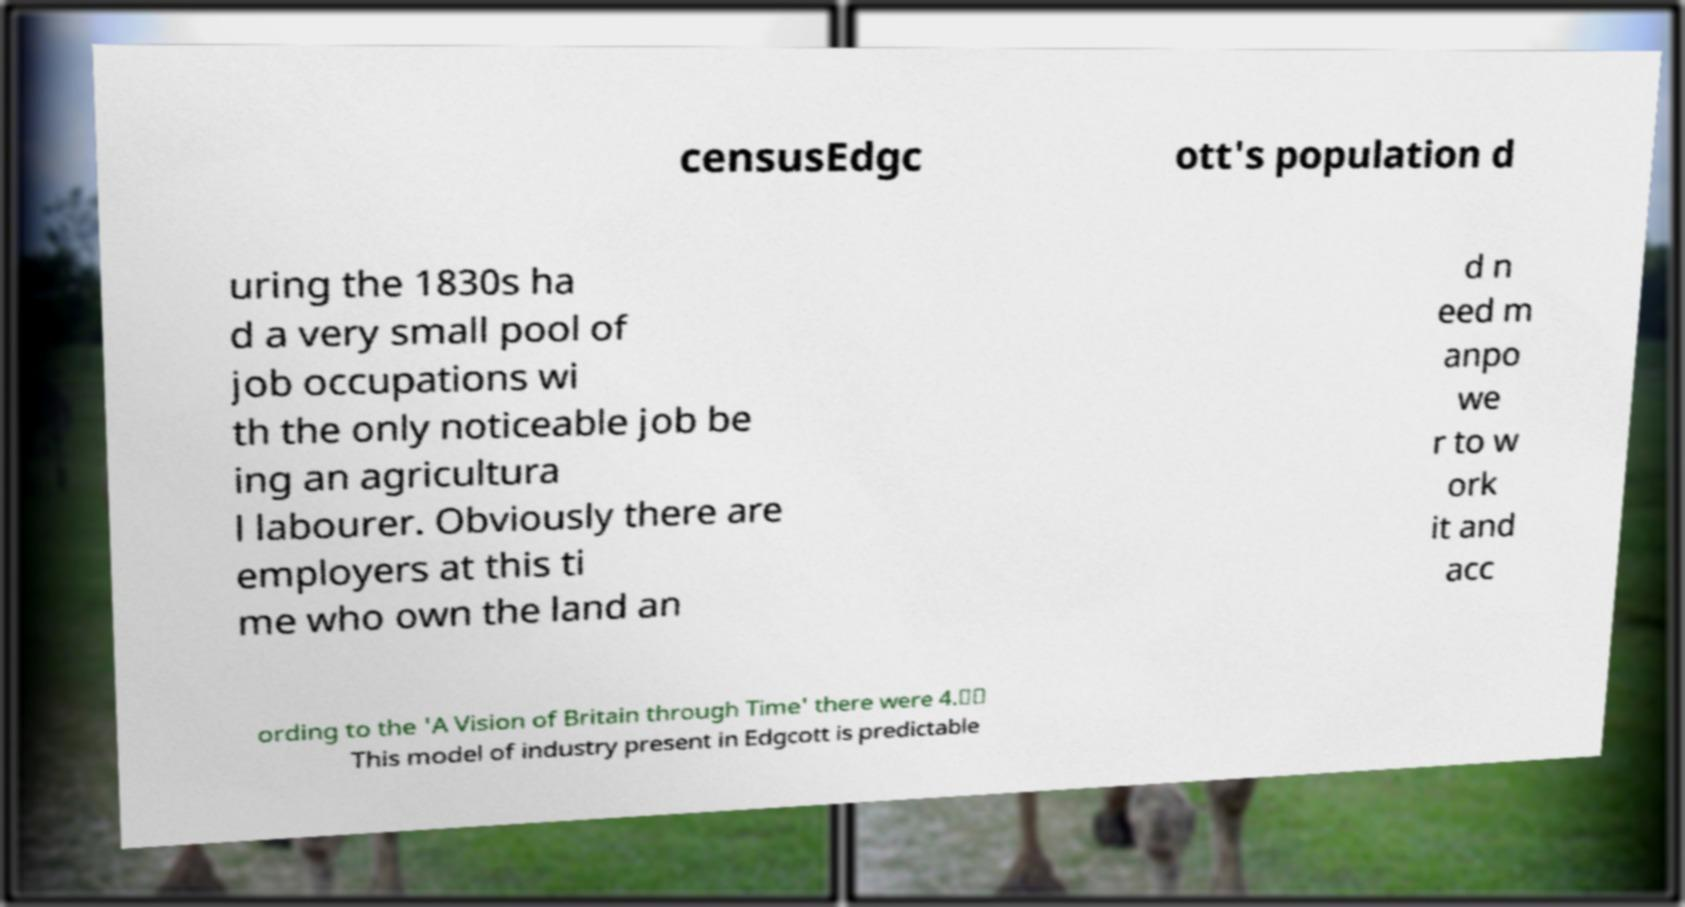Could you extract and type out the text from this image? censusEdgc ott's population d uring the 1830s ha d a very small pool of job occupations wi th the only noticeable job be ing an agricultura l labourer. Obviously there are employers at this ti me who own the land an d n eed m anpo we r to w ork it and acc ording to the 'A Vision of Britain through Time' there were 4.☃☃ This model of industry present in Edgcott is predictable 